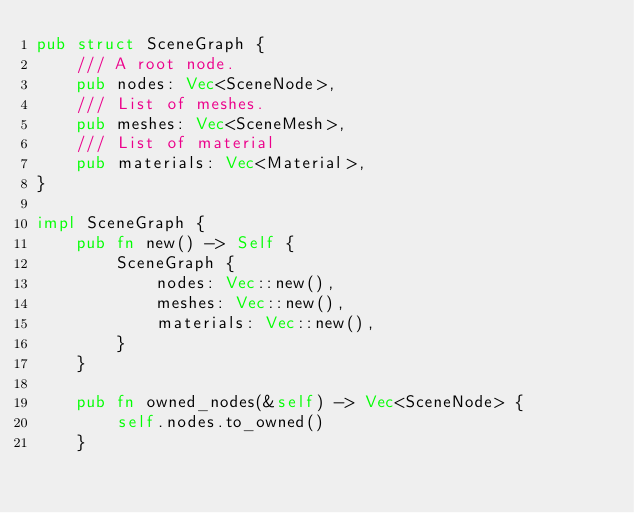<code> <loc_0><loc_0><loc_500><loc_500><_Rust_>pub struct SceneGraph {
    /// A root node.
    pub nodes: Vec<SceneNode>,
    /// List of meshes.
    pub meshes: Vec<SceneMesh>,
    /// List of material
    pub materials: Vec<Material>,
}

impl SceneGraph {
    pub fn new() -> Self {
        SceneGraph {
            nodes: Vec::new(),
            meshes: Vec::new(),
            materials: Vec::new(),
        }
    }

    pub fn owned_nodes(&self) -> Vec<SceneNode> {
        self.nodes.to_owned()
    }
</code> 